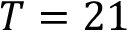<formula> <loc_0><loc_0><loc_500><loc_500>T = 2 1</formula> 